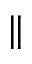Convert formula to latex. <formula><loc_0><loc_0><loc_500><loc_500>\|</formula> 